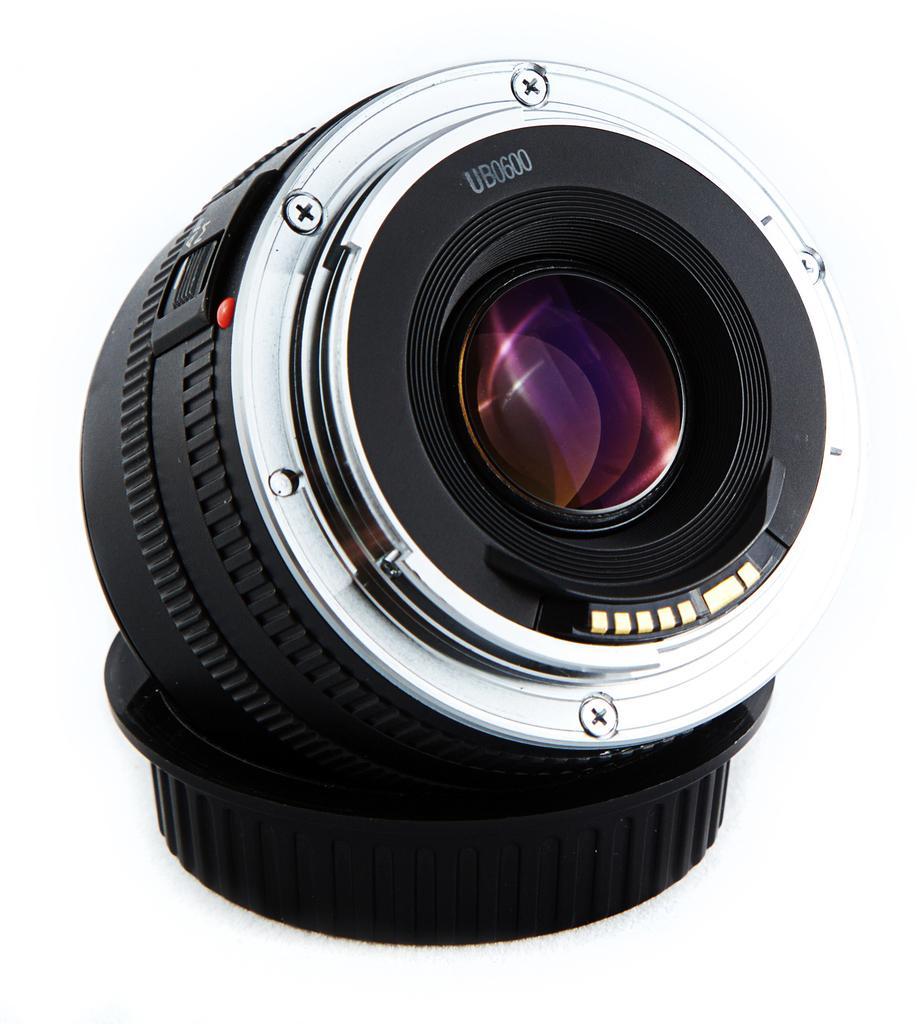Describe this image in one or two sentences. In this image we can see a camera lens and the background is white. 